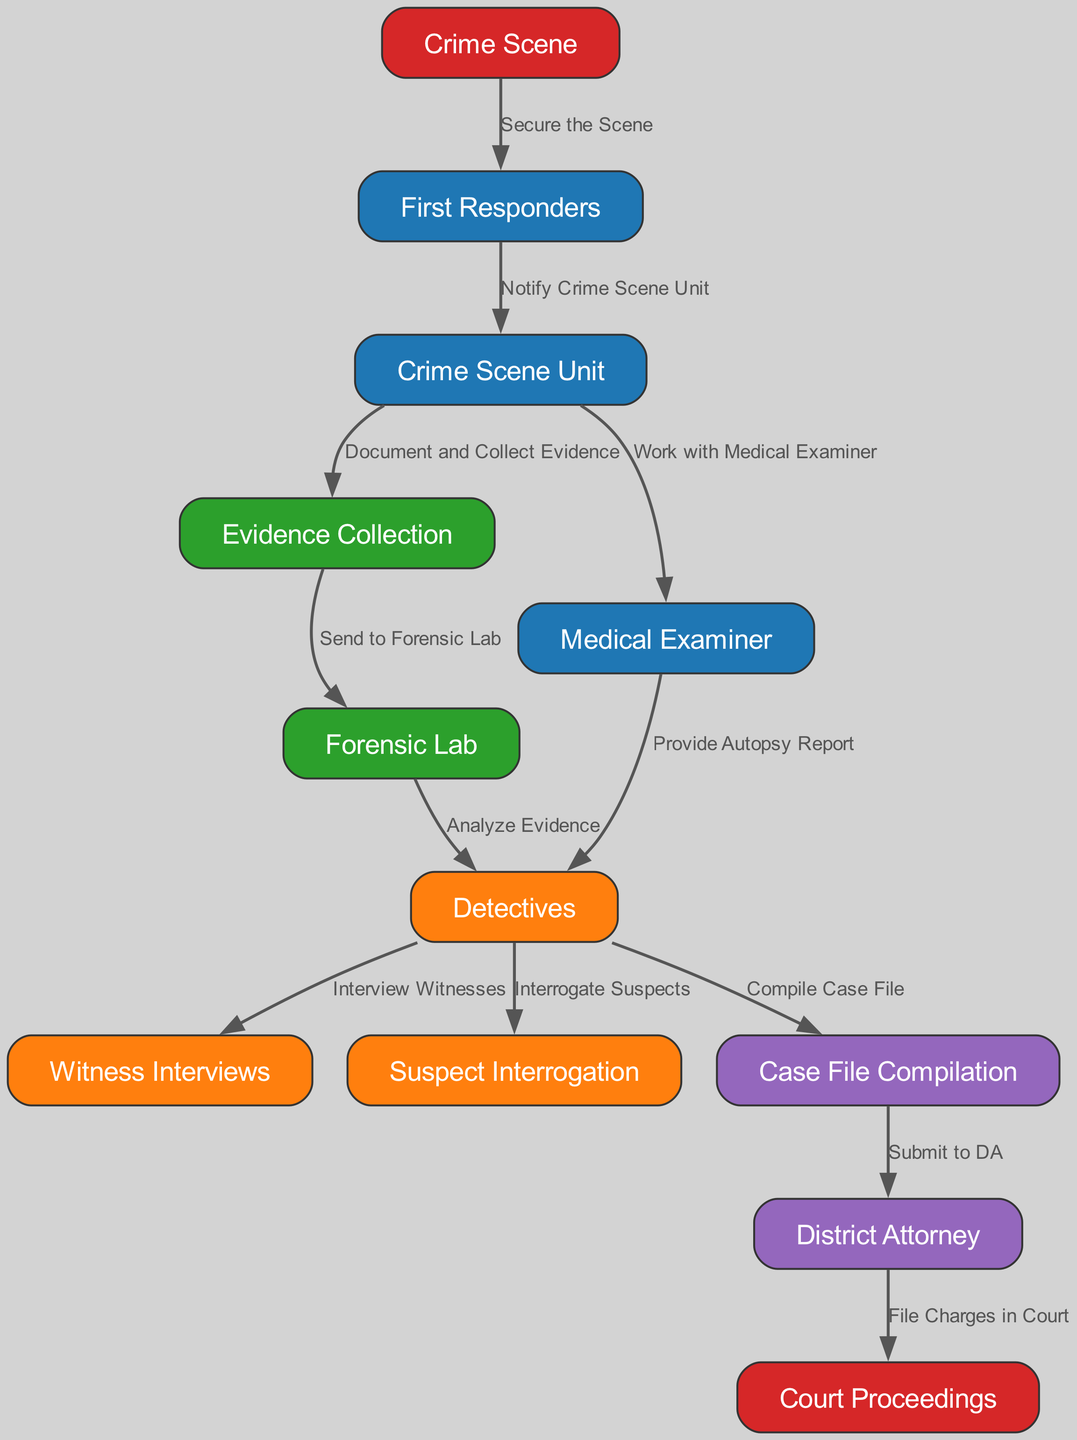What is the starting point of the investigation? The diagram indicates that the investigation begins at "Crime Scene." This is represented as the first node in the flowchart.
Answer: Crime Scene Who is notified after the first responders secure the scene? According to the diagram, after the first responders secure the scene, they notify the "Crime Scene Unit" as the next step in the process.
Answer: Crime Scene Unit How many distinct roles are involved in the investigation process? The diagram shows a total of 12 different nodes, each representing a role or process involved in the investigation. This includes various personnel such as detectives, first responders, and the district attorney among others.
Answer: 12 What is the role of the medical examiner? The diagram illustrates that the medical examiner provides the "Autopsy Report" to the detectives, indicating that their role is to examine bodies and determine the cause of death.
Answer: Provide Autopsy Report What comes after the evidence collection step? In the diagram, the evidence collection step leads to sending the collected evidence to the "Forensic Lab" for further analysis. This follows directly in the sequence of actions outlined.
Answer: Send to Forensic Lab What is the final step in the investigative reporting process? The last step in the diagram is "Court Proceedings," which indicates that after the district attorney files charges, the case proceeds to court for judicial review.
Answer: Court Proceedings Which personnel work together after evidence collection? According to the diagram, after evidence collection, the "Crime Scene Unit" works with the "Medical Examiner," indicating a collaborative process to understand the evidence relating to the deceased.
Answer: Work with Medical Examiner How many edges are there connecting the nodes in this diagram? The diagram features 11 edges that represent the relationships and flow between the nodes. This can be counted by observing each connection between the different roles and processes displayed.
Answer: 11 What is submitted to the district attorney after the detectives compile the case file? The detectives submit the compiled "Case File" to the district attorney as shown in the sequence within the diagram. This step is crucial for the legal proceedings that follow.
Answer: Submit to DA 